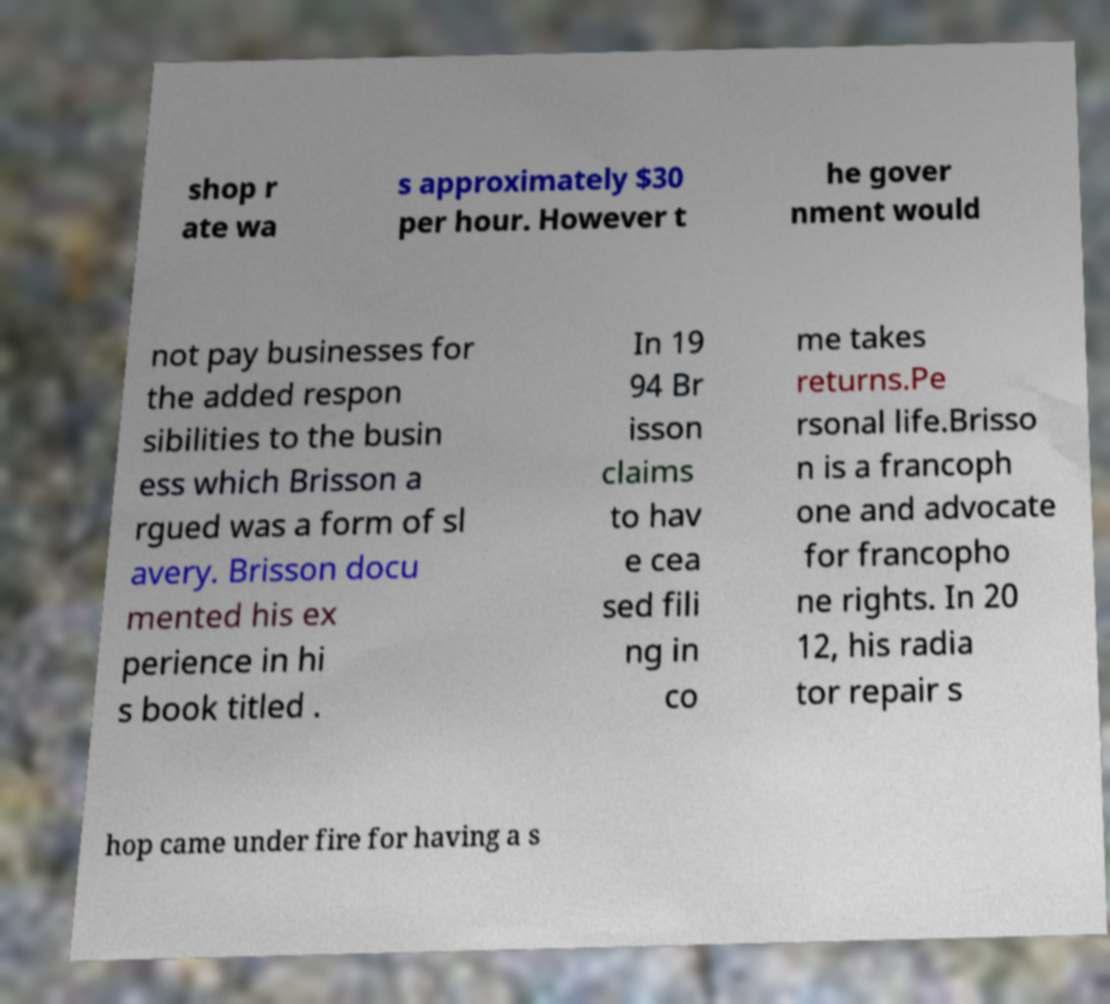For documentation purposes, I need the text within this image transcribed. Could you provide that? shop r ate wa s approximately $30 per hour. However t he gover nment would not pay businesses for the added respon sibilities to the busin ess which Brisson a rgued was a form of sl avery. Brisson docu mented his ex perience in hi s book titled . In 19 94 Br isson claims to hav e cea sed fili ng in co me takes returns.Pe rsonal life.Brisso n is a francoph one and advocate for francopho ne rights. In 20 12, his radia tor repair s hop came under fire for having a s 